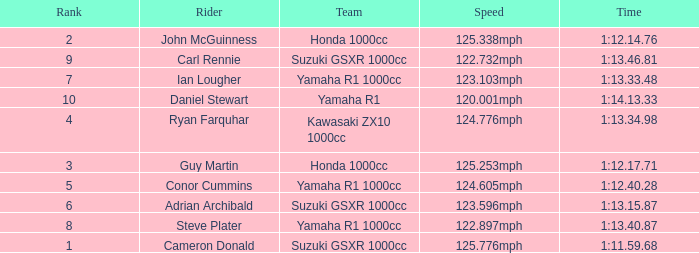What time did team kawasaki zx10 1000cc have? 1:13.34.98. 